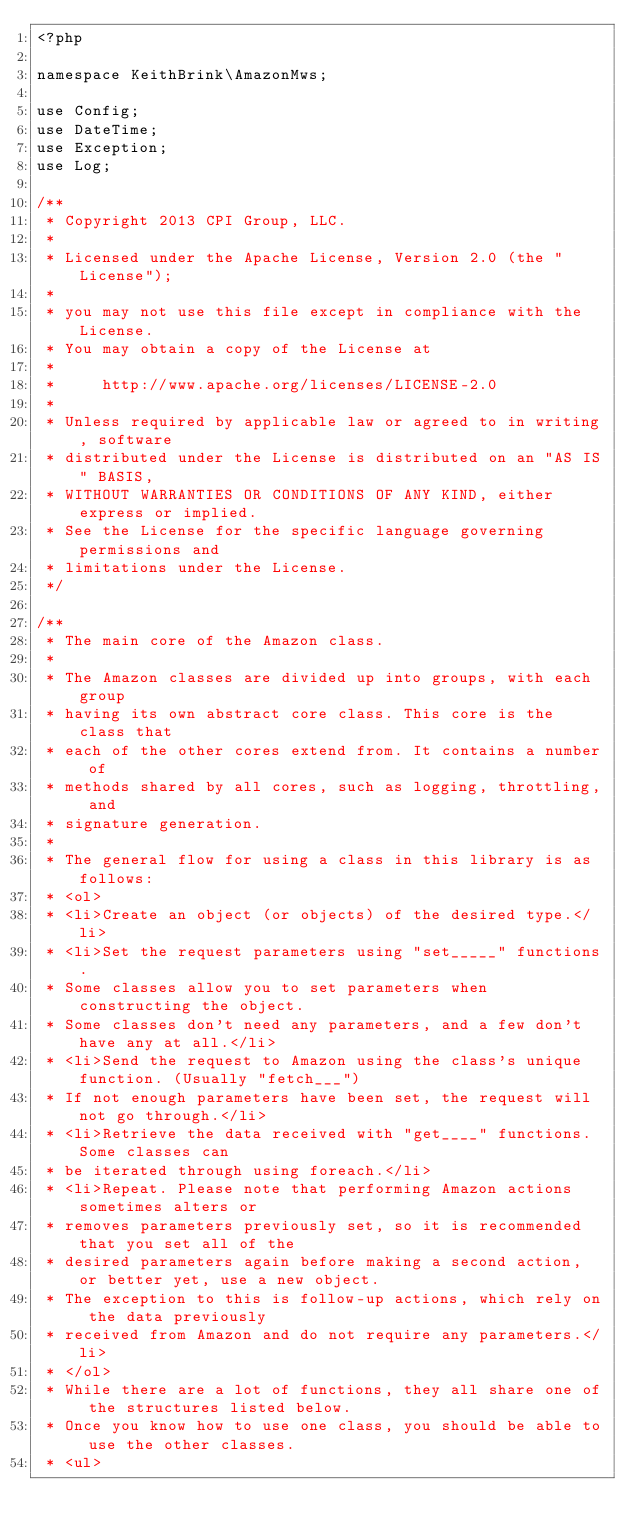<code> <loc_0><loc_0><loc_500><loc_500><_PHP_><?php

namespace KeithBrink\AmazonMws;

use Config;
use DateTime;
use Exception;
use Log;

/**
 * Copyright 2013 CPI Group, LLC.
 *
 * Licensed under the Apache License, Version 2.0 (the "License");
 *
 * you may not use this file except in compliance with the License.
 * You may obtain a copy of the License at
 *
 *     http://www.apache.org/licenses/LICENSE-2.0
 *
 * Unless required by applicable law or agreed to in writing, software
 * distributed under the License is distributed on an "AS IS" BASIS,
 * WITHOUT WARRANTIES OR CONDITIONS OF ANY KIND, either express or implied.
 * See the License for the specific language governing permissions and
 * limitations under the License.
 */

/**
 * The main core of the Amazon class.
 *
 * The Amazon classes are divided up into groups, with each group
 * having its own abstract core class. This core is the class that
 * each of the other cores extend from. It contains a number of
 * methods shared by all cores, such as logging, throttling, and
 * signature generation.
 *
 * The general flow for using a class in this library is as follows:
 * <ol>
 * <li>Create an object (or objects) of the desired type.</li>
 * <li>Set the request parameters using "set_____" functions.
 * Some classes allow you to set parameters when constructing the object.
 * Some classes don't need any parameters, and a few don't have any at all.</li>
 * <li>Send the request to Amazon using the class's unique function. (Usually "fetch___")
 * If not enough parameters have been set, the request will not go through.</li>
 * <li>Retrieve the data received with "get____" functions. Some classes can
 * be iterated through using foreach.</li>
 * <li>Repeat. Please note that performing Amazon actions sometimes alters or
 * removes parameters previously set, so it is recommended that you set all of the
 * desired parameters again before making a second action, or better yet, use a new object.
 * The exception to this is follow-up actions, which rely on the data previously
 * received from Amazon and do not require any parameters.</li>
 * </ol>
 * While there are a lot of functions, they all share one of the structures listed below.
 * Once you know how to use one class, you should be able to use the other classes.
 * <ul></code> 